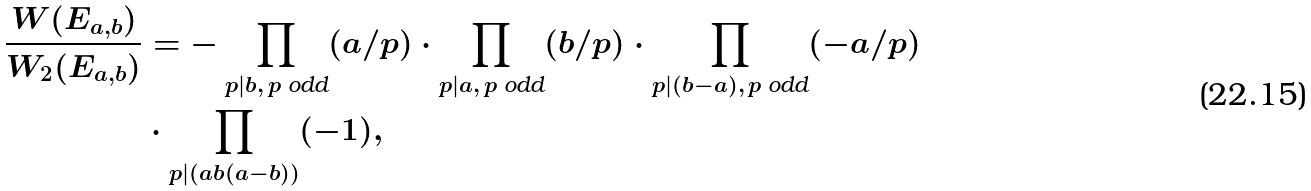Convert formula to latex. <formula><loc_0><loc_0><loc_500><loc_500>\frac { W ( E _ { a , b } ) } { W _ { 2 } ( E _ { a , b } ) } & = - \prod _ { p | b , \, \text {$p$ odd} } ( a / p ) \cdot \prod _ { p | a , \, \text {$p$ odd} } ( b / p ) \cdot \prod _ { p | ( b - a ) , \, \text {$p$ odd} } ( - a / p ) \\ & \cdot \prod _ { p | ( a b ( a - b ) ) } ( - 1 ) ,</formula> 